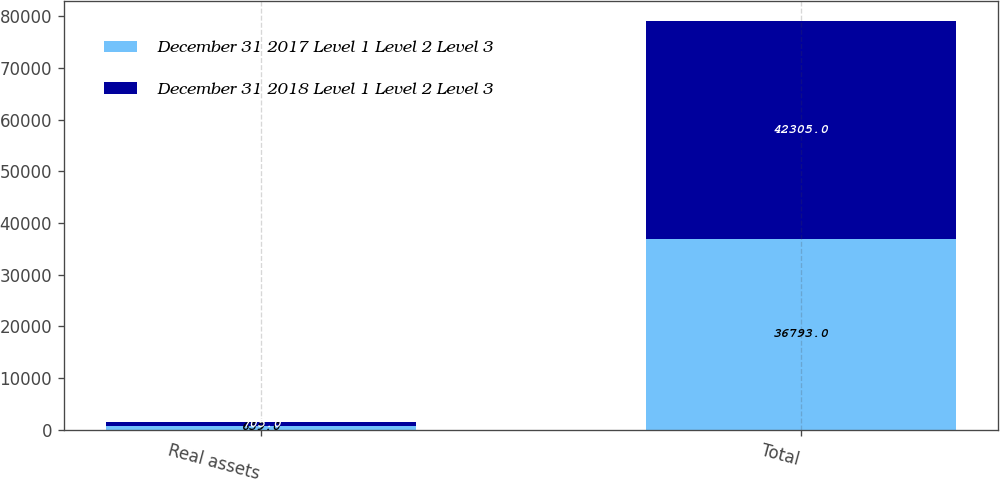Convert chart. <chart><loc_0><loc_0><loc_500><loc_500><stacked_bar_chart><ecel><fcel>Real assets<fcel>Total<nl><fcel>December 31 2017 Level 1 Level 2 Level 3<fcel>659<fcel>36793<nl><fcel>December 31 2018 Level 1 Level 2 Level 3<fcel>705<fcel>42305<nl></chart> 